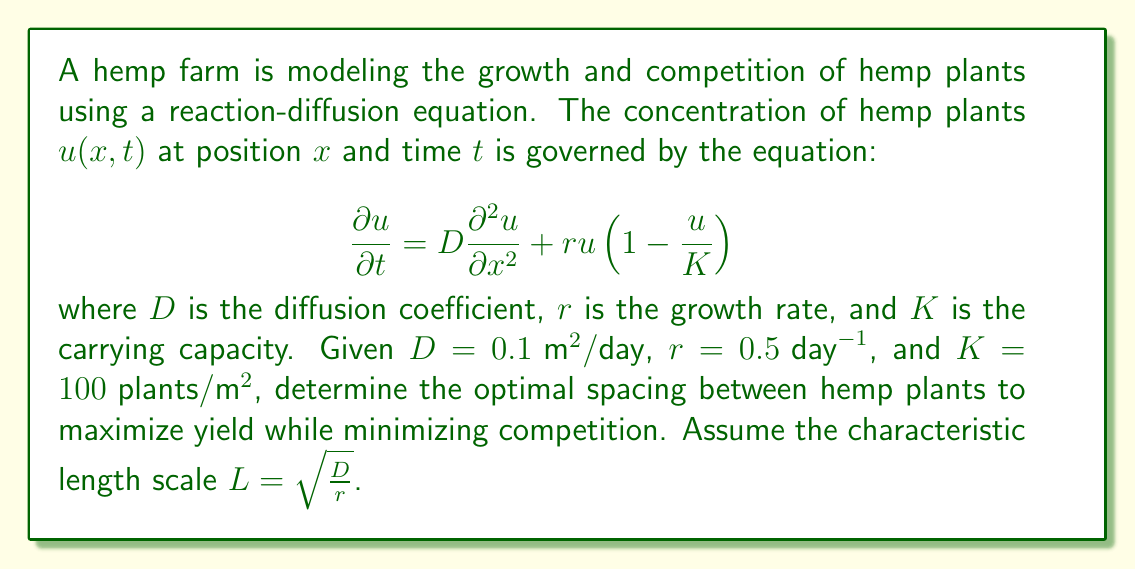Solve this math problem. To determine the optimal spacing between hemp plants, we need to calculate the characteristic length scale $L$, which represents the distance over which the plants significantly interact with each other.

1) First, let's calculate $L$:
   
   $$L = \sqrt{\frac{D}{r}} = \sqrt{\frac{0.1 \text{ m}^2/\text{day}}{0.5 \text{ day}^{-1}}} = \sqrt{0.2 \text{ m}^2} = 0.447 \text{ m}$$

2) The characteristic length scale $L$ gives us an estimate of the optimal spacing between plants. Plants spaced closer than this distance will compete more strongly for resources, while plants spaced further apart may not efficiently use the available space.

3) In practice, the optimal spacing is often taken to be between $L$ and $2L$. This range allows for some interaction between plants (which can sometimes be beneficial) while avoiding excessive competition.

4) Therefore, the optimal spacing range would be:
   
   $$0.447 \text{ m} \leq \text{Optimal Spacing} \leq 0.894 \text{ m}$$

5) Considering the regulatory and industry standards, it's common to round these values to practical measurements. We can round these to:
   
   $$0.45 \text{ m} \leq \text{Optimal Spacing} \leq 0.90 \text{ m}$$

6) The midpoint of this range, which balances the benefits of interaction with the drawbacks of competition, would be:
   
   $$\text{Optimal Spacing} \approx 0.675 \text{ m}$$

This spacing should maximize yield while minimizing competition between hemp plants, given the parameters of the reaction-diffusion model.
Answer: The optimal spacing between hemp plants is approximately 0.675 m (67.5 cm). 